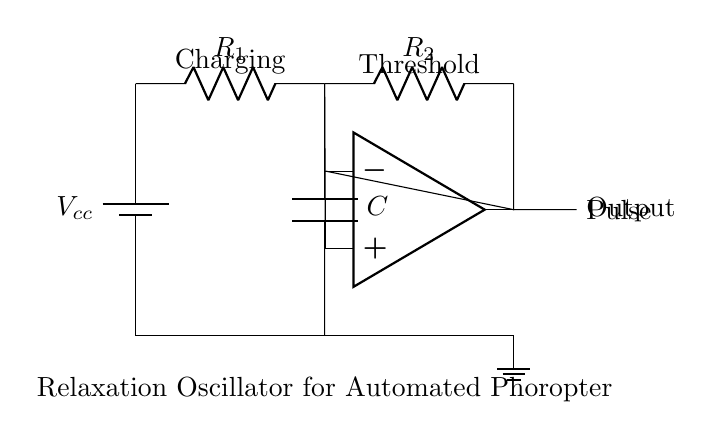What type of circuit is represented? The circuit is a relaxation oscillator, as indicated by the configuration of components designed to generate periodic pulses.
Answer: relaxation oscillator What is the role of the capacitor in this circuit? The capacitor serves to store and release charge, which is crucial for the timing mechanism of the oscillator; it charges through the resistors and then discharges to create the output pulse.
Answer: timing What components are used to create the pulse output? The pulse output is generated by the operational amplifier in conjunction with the charging and discharging behavior of the capacitor connected with resistors.
Answer: operational amplifier How many resistors are present in the circuit? There are two resistors, labeled R1 and R2, which control the charging rate of the capacitor and therefore influence the frequency of the oscillation.
Answer: two What happens when the voltage across the capacitor reaches the threshold? Once the voltage across the capacitor reaches the threshold set by the operational amplifier, the output changes state, causing the pulse to be generated.
Answer: output changes What is the purpose of the battery in the circuit? The battery provides the necessary power supply (Vcc) that enables the circuit to function, ensuring there is a voltage difference for the charging process.
Answer: power supply What effect does increasing resistors R1 and R2 have on the pulse frequency? Increasing the resistance values of R1 and R2 will slow down the charging time of the capacitor, resulting in a lower pulse frequency.
Answer: decreases frequency 